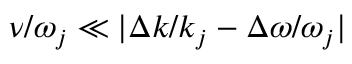Convert formula to latex. <formula><loc_0><loc_0><loc_500><loc_500>\nu / \omega _ { j } \ll | \Delta k / k _ { j } - \Delta \omega / \omega _ { j } |</formula> 